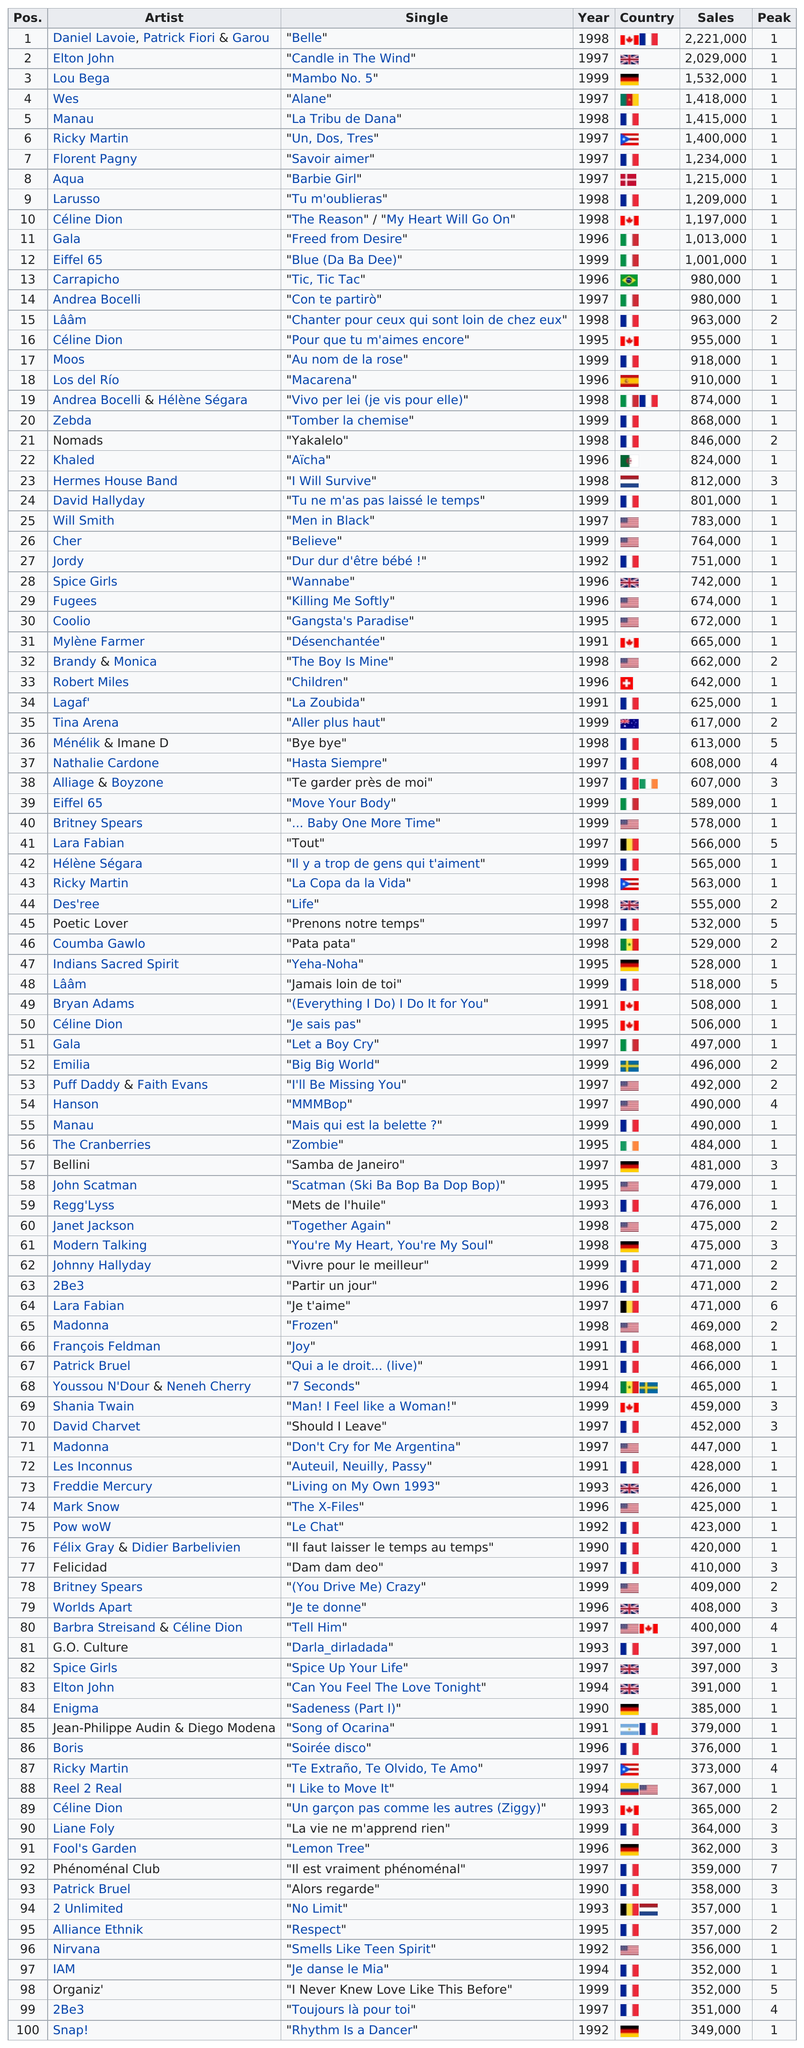Draw attention to some important aspects in this diagram. Con te partirò" has the same number of sales as "Tic, tic tac". According to sales data, Eiffel 65's single "Blue (Da Ba Dee)" sold a total of 1,001,000 units. Celine Dion sang a total of four singles. It is not clear whether Ricky Martin or Eiffel 65 ranked higher on the list of top 100 songs of the 1990s. Eiffel 65 had a top 100 hit of the 1990s with "Blue (Da Ba Dee)," which reached number three on the UK Singles Chart, and also had another top 100 hit single, "Move Your Body," which reached number two on the UK Singles Chart. 